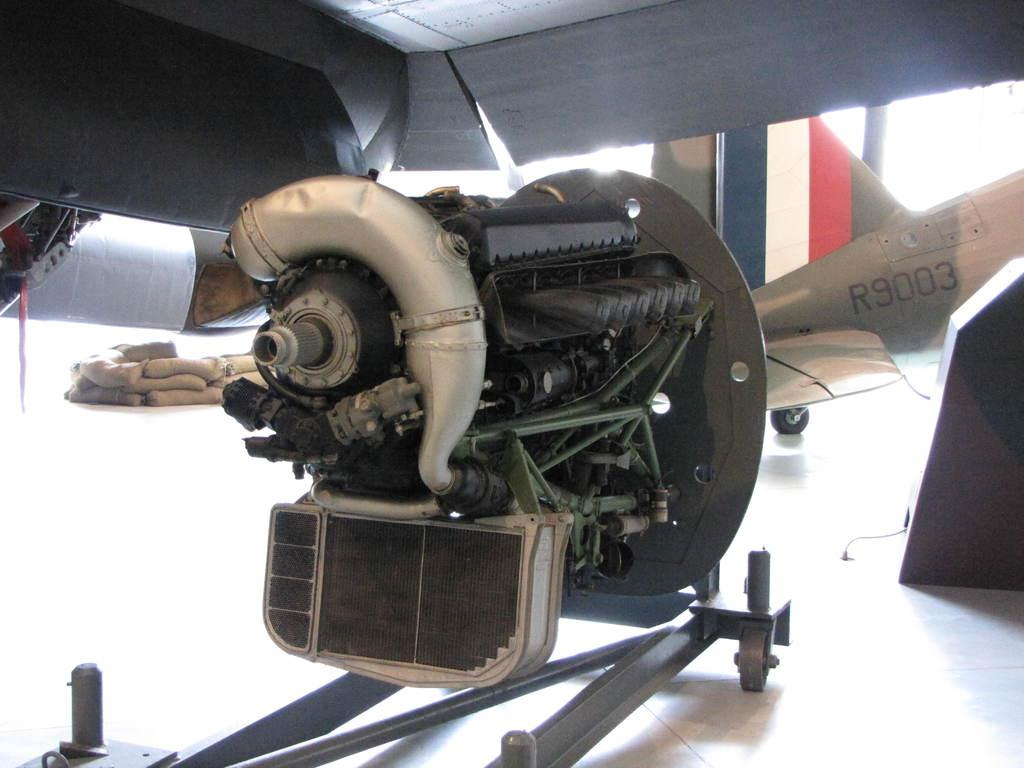What is the main mechanical component in the image? There is an engine in the image. What type of vehicle is associated with the engine? There is an aeroplane in the image. What items can be seen near the engine or aeroplane? There are bags in the image. What surface is visible in the image? There is a floor in the image. What type of material is used for some of the objects in the image? There are metal objects in the image. Can you see any fairies flying around the engine in the image? There are no fairies present in the image. What type of test is being conducted on the aeroplane in the image? There is no test being conducted on the aeroplane in the image. 